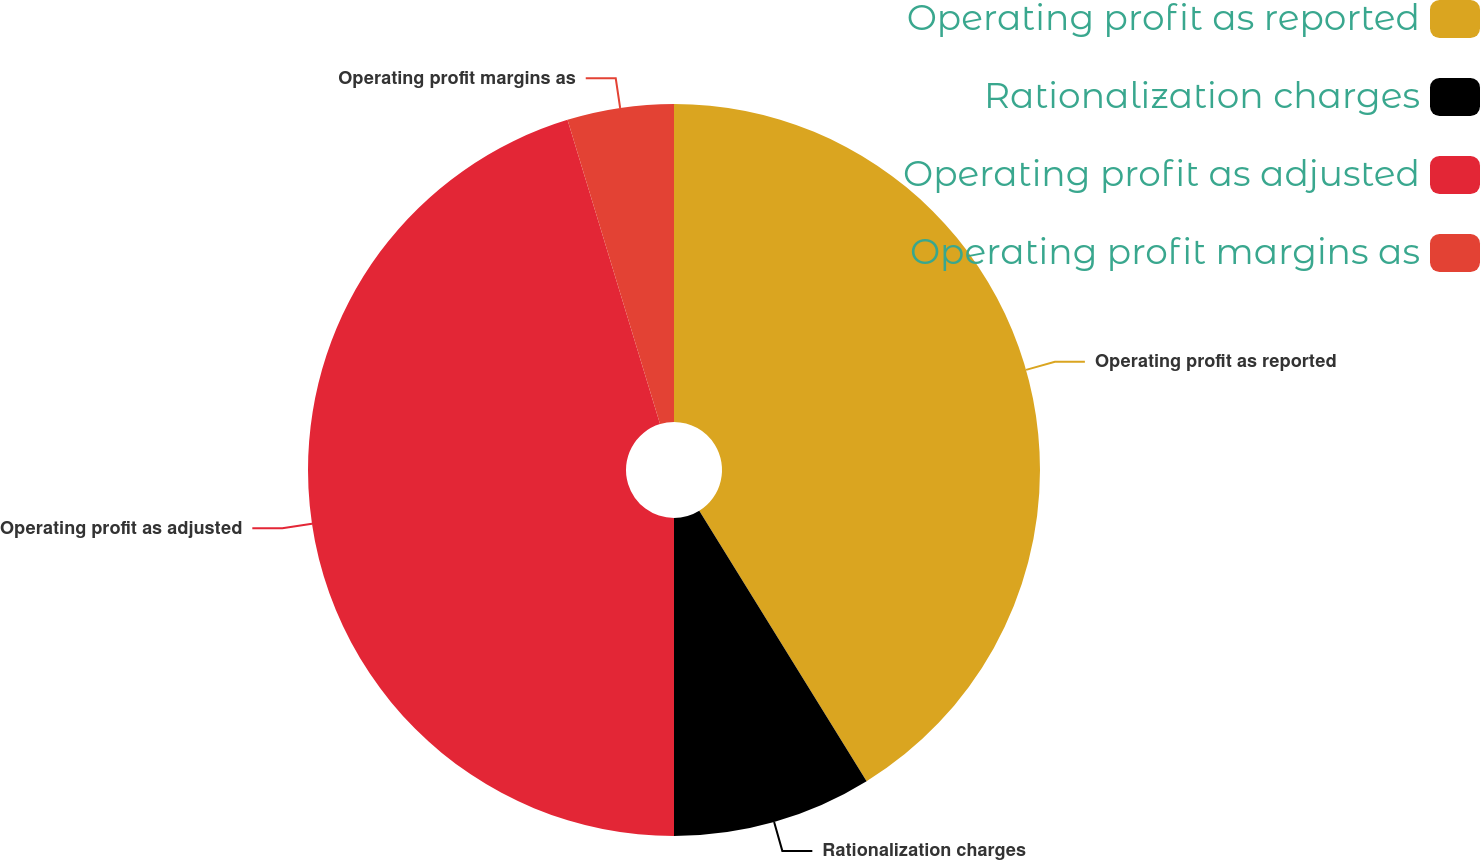<chart> <loc_0><loc_0><loc_500><loc_500><pie_chart><fcel>Operating profit as reported<fcel>Rationalization charges<fcel>Operating profit as adjusted<fcel>Operating profit margins as<nl><fcel>41.18%<fcel>8.82%<fcel>45.3%<fcel>4.7%<nl></chart> 